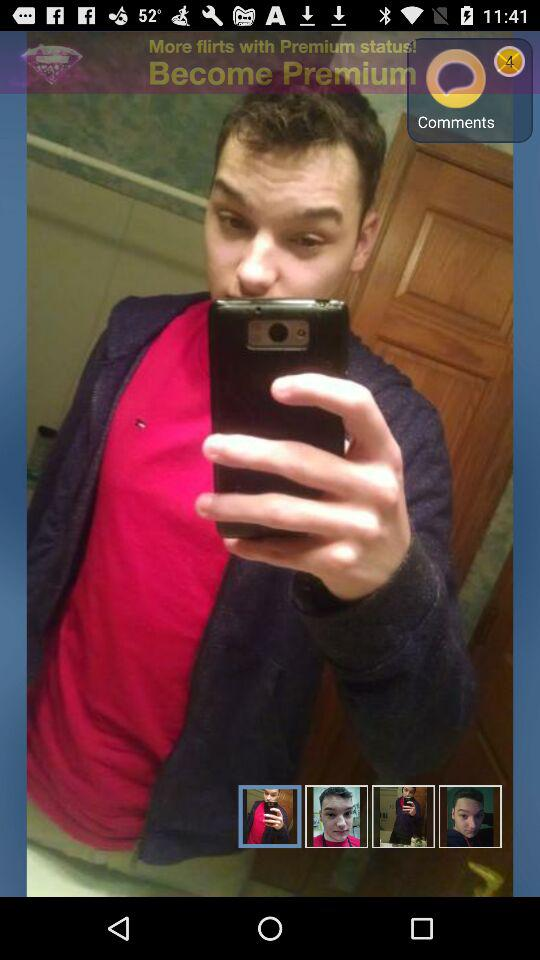How many comments are there? There are 4 comments. 